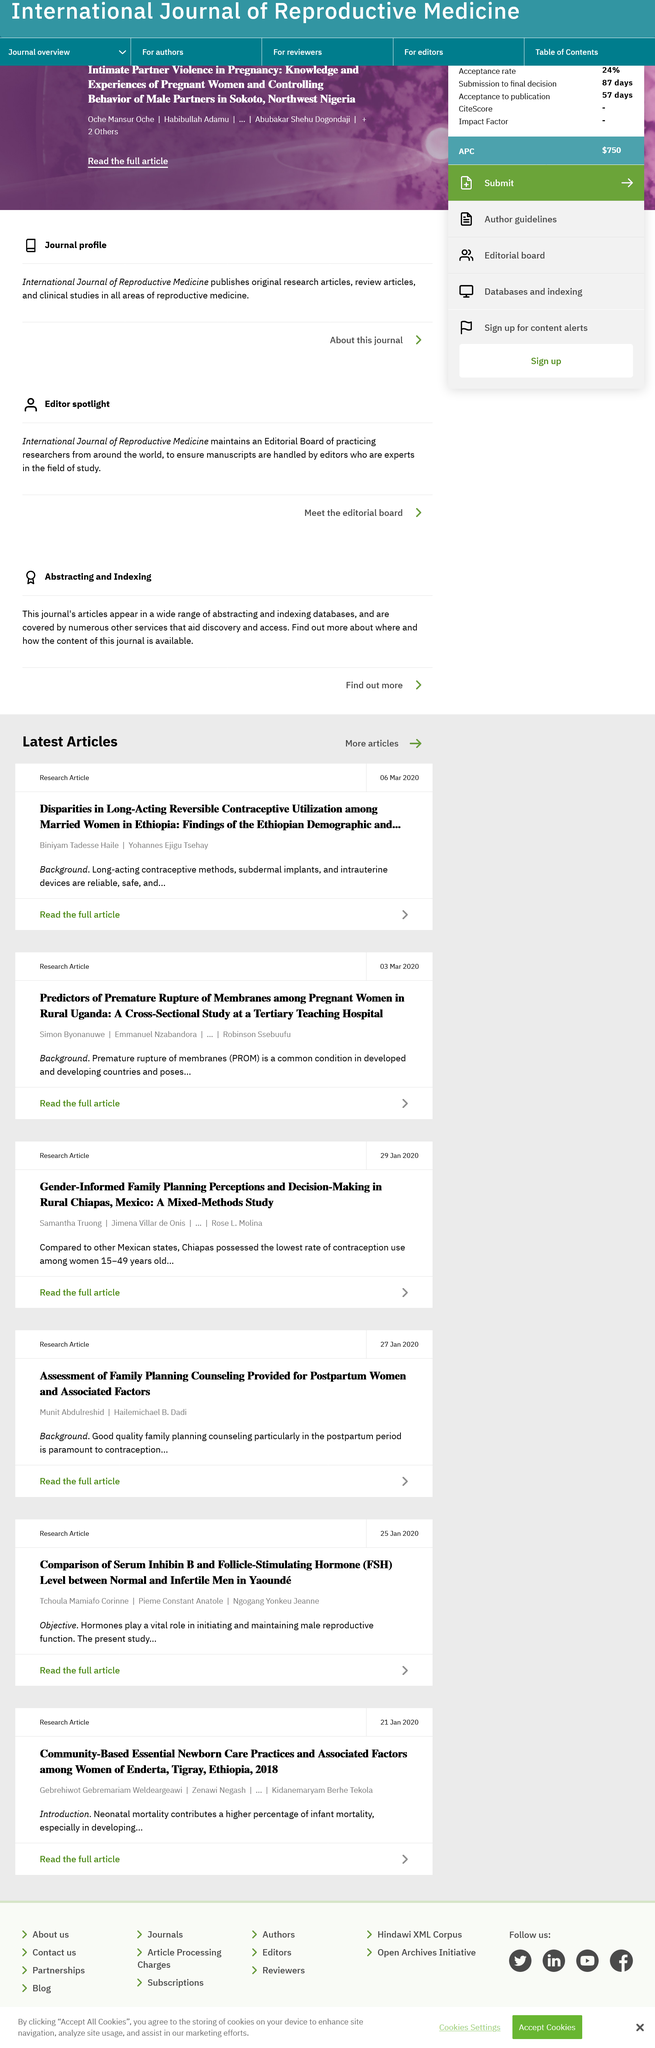Point out several critical features in this image. The study did not include pregnant women from city areas, but rather focused on pregnant women in rural Uganda. The study was conducted at a Tertiary Teaching Hospital. PROM stands for Premature Rupture of Membranes. 